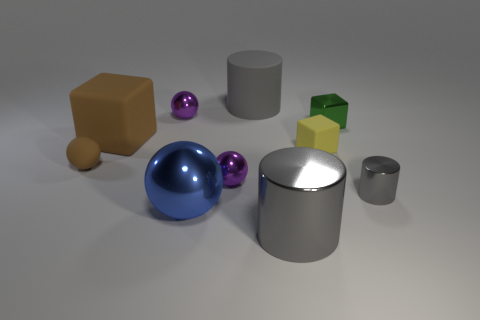How many gray cylinders must be subtracted to get 1 gray cylinders? 2 Subtract 1 spheres. How many spheres are left? 3 Subtract all gray balls. Subtract all brown cylinders. How many balls are left? 4 Subtract all balls. How many objects are left? 6 Subtract all tiny brown things. Subtract all matte blocks. How many objects are left? 7 Add 1 small gray metallic cylinders. How many small gray metallic cylinders are left? 2 Add 6 large brown rubber blocks. How many large brown rubber blocks exist? 7 Subtract 1 green cubes. How many objects are left? 9 